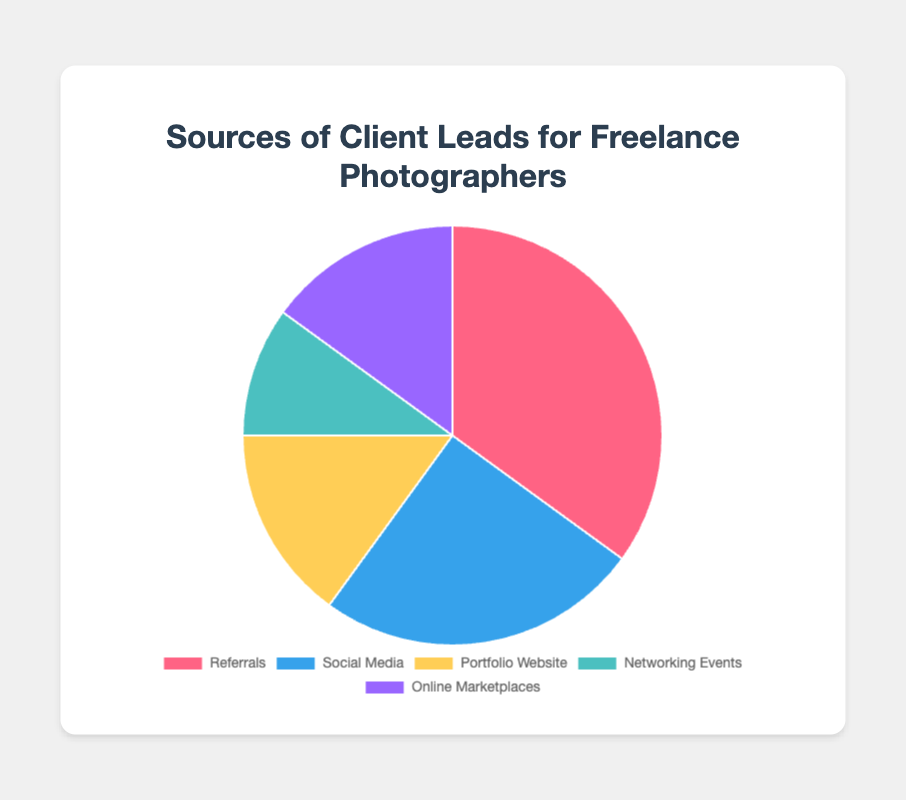Which source has the highest percentage of client leads? Referrals have the highest percentage at 35, as indicated by the largest section of the pie chart.
Answer: Referrals What's the combined percentage of leads from the Portfolio Website and Online Marketplaces? The percentages from Portfolio Website and Online Marketplaces are 15 each. Adding them together, we get 15 + 15 = 30.
Answer: 30 How much more percentage do Referrals contribute compared to Networking Events? Referrals contribute 35% while Networking Events contribute 10%. The difference is 35 - 10 = 25.
Answer: 25 Is the percentage of leads from Social Media greater than that from Networking Events? Social Media has 25% and Networking Events have 10%. Since 25% is greater than 10%, the answer is yes.
Answer: Yes Which sources of client leads have the same percentage? The Portfolio Website and Online Marketplaces both have a percentage of 15%, as indicated by equal-sized sections of the pie chart.
Answer: Portfolio Website and Online Marketplaces Is the total percentage of leads from Referrals and Social Media more than half of the total leads? Adding percentages from Referrals (35%) and Social Media (25%), we get 35 + 25 = 60. Since 60% is more than 50%, the answer is yes.
Answer: Yes What is the average percentage of leads from all sources? Sum the percentages: 35 (Referrals) + 25 (Social Media) + 15 (Portfolio Website) + 10 (Networking Events) + 15 (Online Marketplaces) = 100. There are 5 data points, so average is 100/5 = 20.
Answer: 20 What percentage of the total leads does the least contributing source provide? Networking Events contribute the least with 10% of the total leads.
Answer: 10 By how much does the percentage of leads from Social Media exceed those from Portfolio Website? Social Media contributes 25% and Portfolio Website contributes 15%. The difference is 25 - 15 = 10.
Answer: 10 Which section of the pie chart is colored blue? The Social Media section of the pie chart is colored blue.
Answer: Social Media 